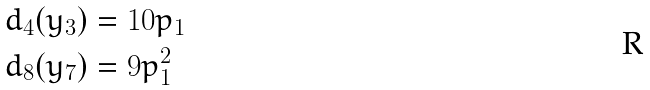Convert formula to latex. <formula><loc_0><loc_0><loc_500><loc_500>d _ { 4 } ( y _ { 3 } ) & = 1 0 p _ { 1 } \\ d _ { 8 } ( y _ { 7 } ) & = 9 p _ { 1 } ^ { 2 }</formula> 